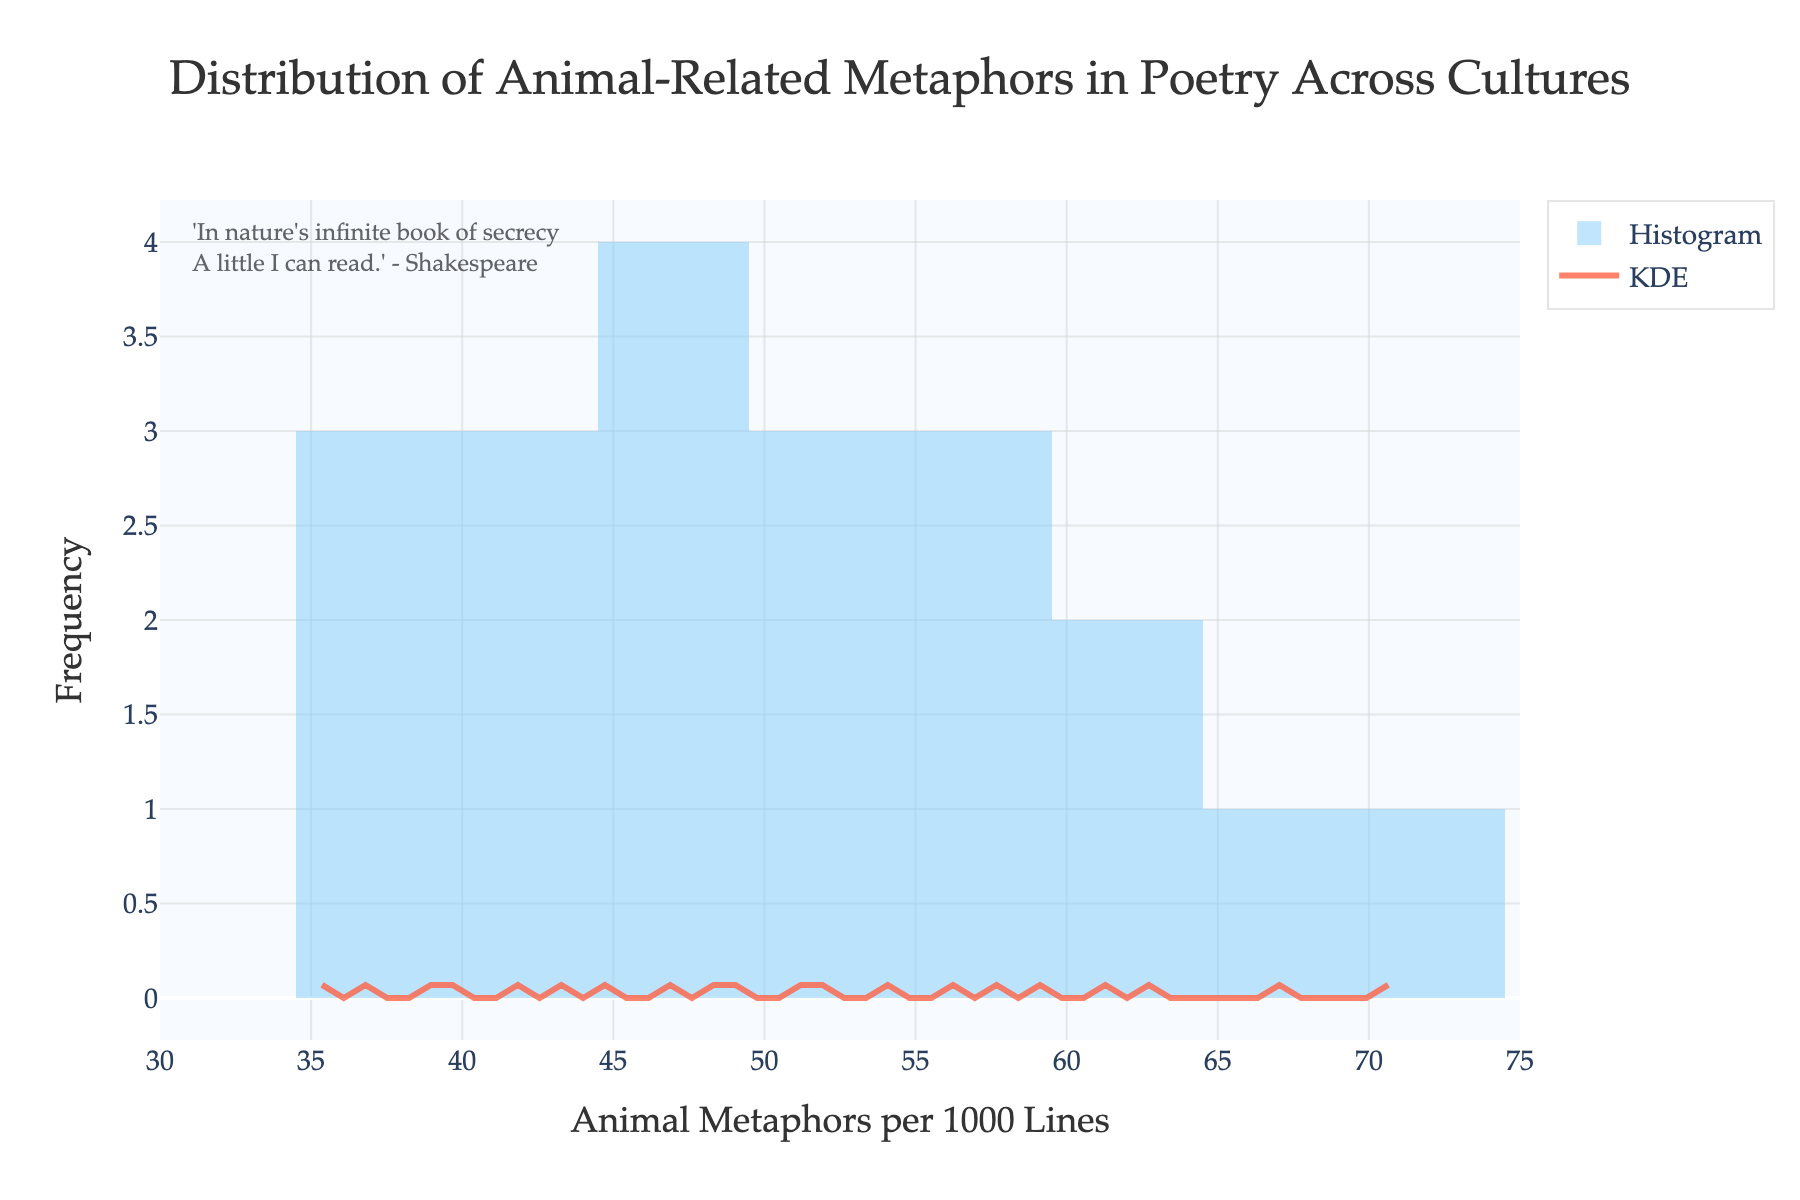What is the range of animal metaphors per 1000 lines in the dataset? The x-axis range in the histogram goes from 30 to 75, showing the range of animal metaphors per 1000 lines in the dataset.
Answer: 30 to 75 Which culture shows the highest occurrence of animal-related metaphors in poetry according to the histogram? By looking at the histogram peaks, the culture with the highest occurrence of animal-related metaphors is Native American, with 71 metaphors per 1000 lines.
Answer: Native American What is the approximate mode value based on the histogram? The mode is the value that appears most frequently. By looking at the highest bar, the approximate mode is near 42 animal metaphors per 1000 lines.
Answer: 42 How many bins are there in the histogram? The histogram shows bins, and they can be counted visually from the bar divisions.
Answer: 15 What does the KDE (density curve) help illustrate in this figure? The KDE provides a smooth estimate of the probability density function of the data, giving insights into the distribution of the animal metaphors without the rigid structure of histogram bins.
Answer: Distribution estimation Which cultures fall into the lower half range of animal metaphors per 1000 lines? Cultures with values below the median (~49 metaphors) include Chinese, Japanese, Russian, Turkish, Korean, and Vietnamese cultures.
Answer: Chinese, Japanese, Russian, Turkish, Korean, Vietnamese What is the density value at the peak of the KDE curve? The peak of the KDE curve represents the maximum density value, which visually can be approximated by tracing back horizontally from the highest point on the curve to the y-axis. This value is approximately 0.04.
Answer: 0.04 Which culture has a frequency of 45 animal metaphors per 1000 lines? By looking at the x-axis and mapping to the histogram bars, it's observed that the French culture shows 45 animal metaphors per 1000 lines.
Answer: French How does the distribution spread between values of 40 and 60 animal metaphors per 1000 lines? Most cultures fall within this range, making it the most frequent interval. The histogram and KDE curves indicate clustering within this range.
Answer: Most frequent Are there any cultures with animal metaphors per 1000 lines below 35? By checking the histogram bars to spots below 35, we observe no culture listed below 35.
Answer: No 